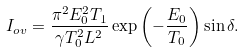Convert formula to latex. <formula><loc_0><loc_0><loc_500><loc_500>I _ { o v } = \frac { \pi ^ { 2 } E _ { 0 } ^ { 2 } T _ { 1 } } { \gamma T _ { 0 } ^ { 2 } L ^ { 2 } } \exp \left ( - \frac { E _ { 0 } } { T _ { 0 } } \right ) \sin \delta .</formula> 